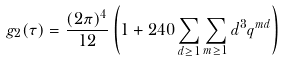<formula> <loc_0><loc_0><loc_500><loc_500>g _ { 2 } ( \tau ) = \frac { ( 2 \pi ) ^ { 4 } } { 1 2 } \left ( 1 + 2 4 0 \sum _ { d \geq 1 } \sum _ { m \geq 1 } d ^ { 3 } q ^ { m d } \right )</formula> 